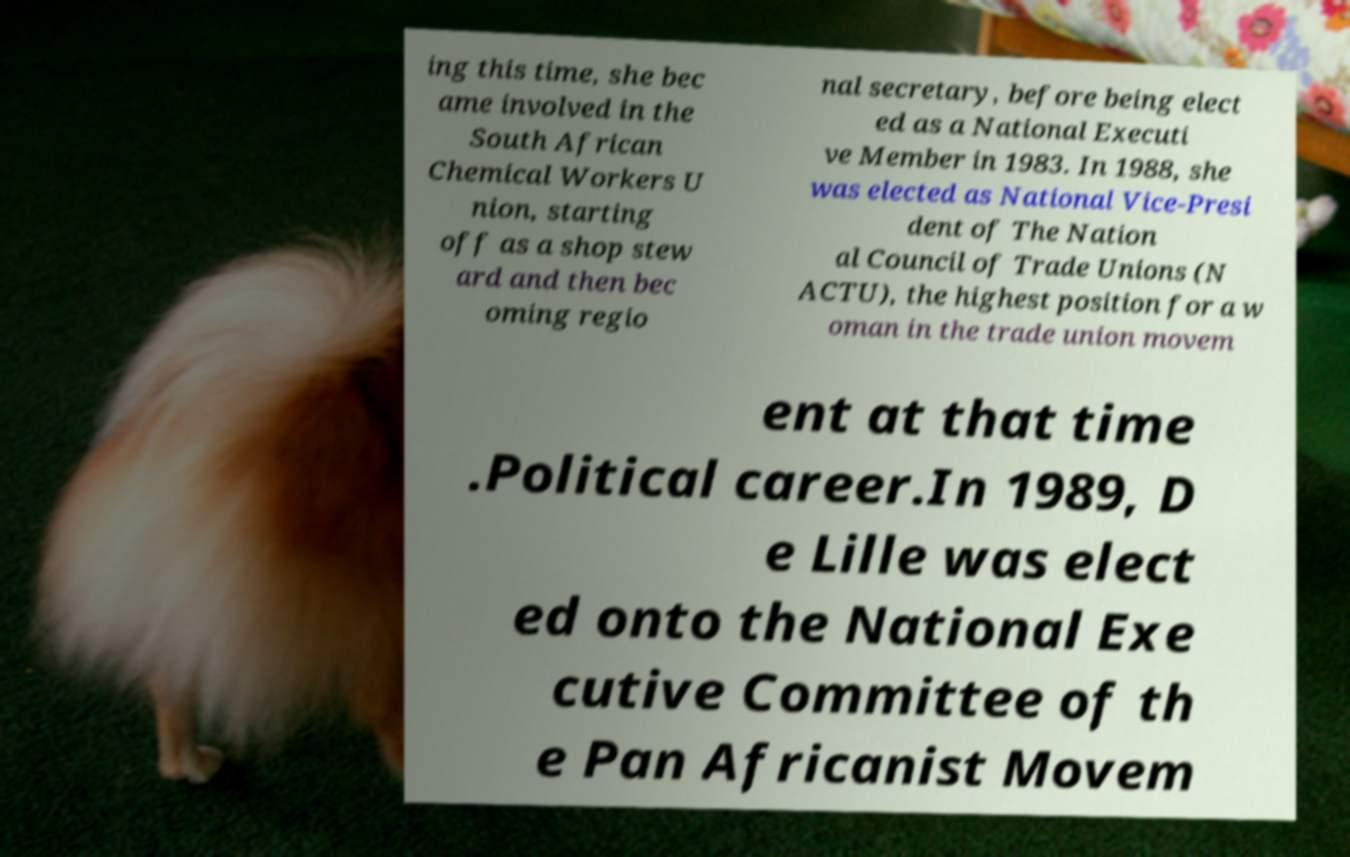Can you read and provide the text displayed in the image?This photo seems to have some interesting text. Can you extract and type it out for me? ing this time, she bec ame involved in the South African Chemical Workers U nion, starting off as a shop stew ard and then bec oming regio nal secretary, before being elect ed as a National Executi ve Member in 1983. In 1988, she was elected as National Vice-Presi dent of The Nation al Council of Trade Unions (N ACTU), the highest position for a w oman in the trade union movem ent at that time .Political career.In 1989, D e Lille was elect ed onto the National Exe cutive Committee of th e Pan Africanist Movem 